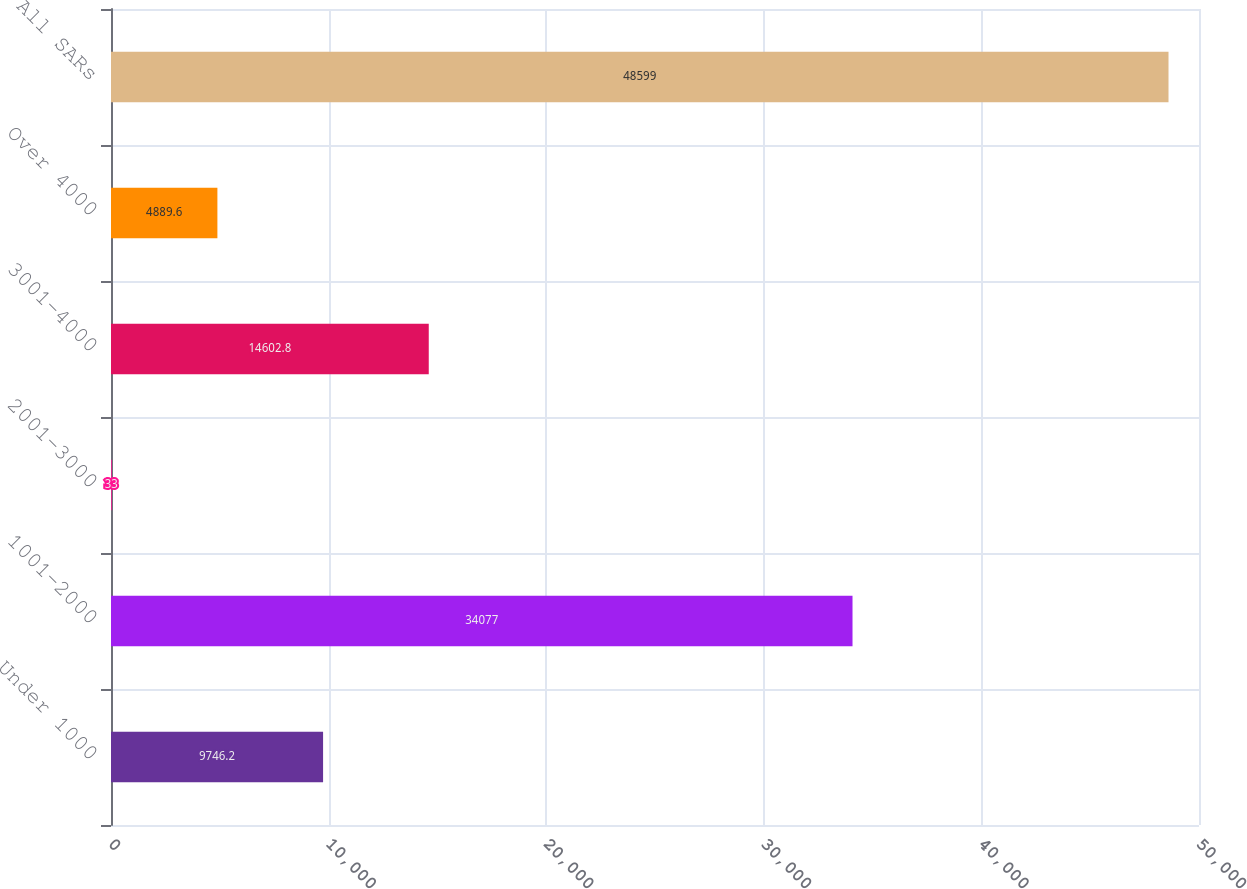Convert chart to OTSL. <chart><loc_0><loc_0><loc_500><loc_500><bar_chart><fcel>Under 1000<fcel>1001-2000<fcel>2001-3000<fcel>3001-4000<fcel>Over 4000<fcel>All SARs<nl><fcel>9746.2<fcel>34077<fcel>33<fcel>14602.8<fcel>4889.6<fcel>48599<nl></chart> 